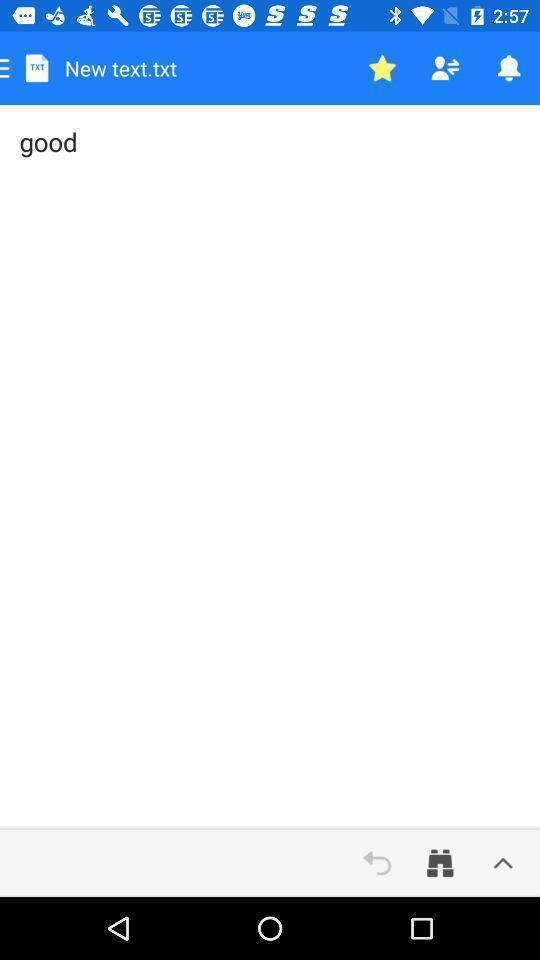Explain what's happening in this screen capture. Screen showing text editing page. 